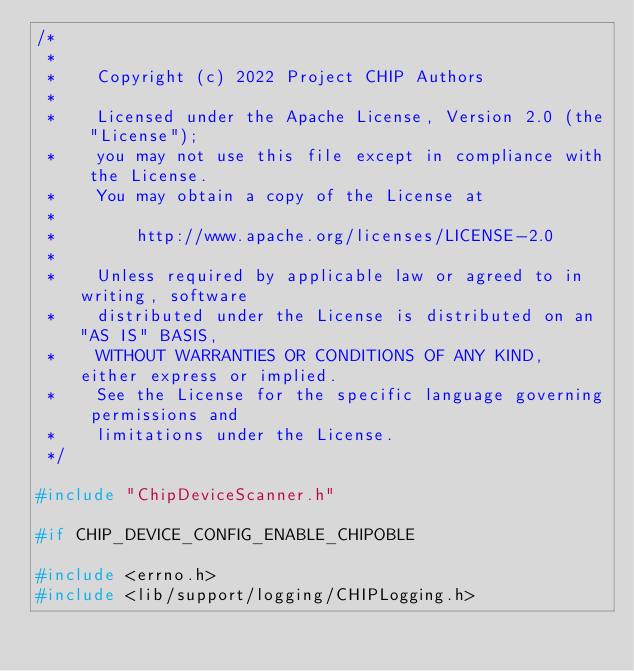Convert code to text. <code><loc_0><loc_0><loc_500><loc_500><_C++_>/*
 *
 *    Copyright (c) 2022 Project CHIP Authors
 *
 *    Licensed under the Apache License, Version 2.0 (the "License");
 *    you may not use this file except in compliance with the License.
 *    You may obtain a copy of the License at
 *
 *        http://www.apache.org/licenses/LICENSE-2.0
 *
 *    Unless required by applicable law or agreed to in writing, software
 *    distributed under the License is distributed on an "AS IS" BASIS,
 *    WITHOUT WARRANTIES OR CONDITIONS OF ANY KIND, either express or implied.
 *    See the License for the specific language governing permissions and
 *    limitations under the License.
 */

#include "ChipDeviceScanner.h"

#if CHIP_DEVICE_CONFIG_ENABLE_CHIPOBLE

#include <errno.h>
#include <lib/support/logging/CHIPLogging.h></code> 